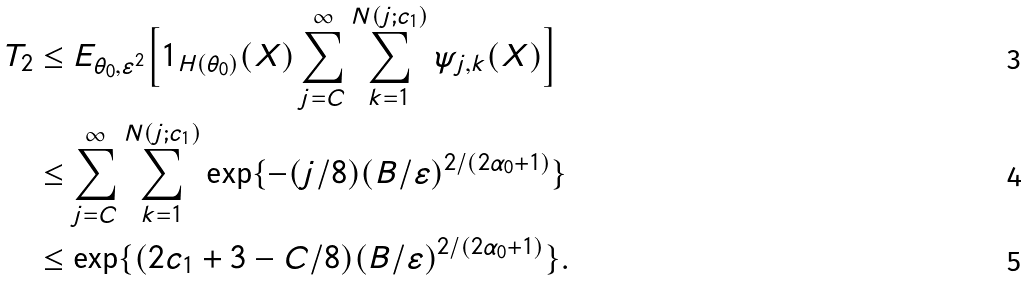<formula> <loc_0><loc_0><loc_500><loc_500>T _ { 2 } & \leq E _ { \theta _ { 0 } , \varepsilon ^ { 2 } } \Big { [ } 1 _ { H ( \theta _ { 0 } ) } ( X ) \sum _ { j = C } ^ { \infty } \sum _ { k = 1 } ^ { N ( j ; c _ { 1 } ) } \psi _ { j , k } ( X ) \Big { ] } \\ & \leq \sum _ { j = C } ^ { \infty } \sum _ { k = 1 } ^ { N ( j ; c _ { 1 } ) } \exp \{ - ( j / 8 ) ( B / \varepsilon ) ^ { 2 / ( 2 \alpha _ { 0 } + 1 ) } \} \\ & \leq \exp \{ ( 2 c _ { 1 } + 3 - C / 8 ) ( B / \varepsilon ) ^ { 2 / ( 2 \alpha _ { 0 } + 1 ) } \} .</formula> 